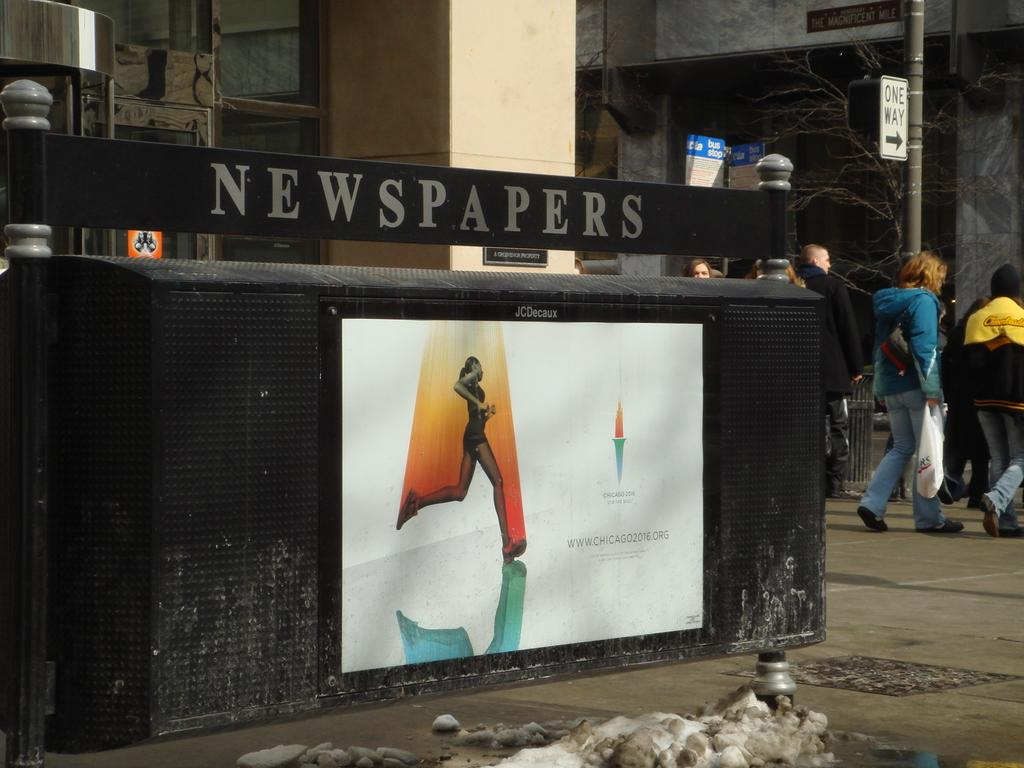How many people are in the image? There are persons in the image, but the exact number is not specified. What can be seen besides the persons in the image? There is a pole and a poster on a wall in the image. Can you describe the poster on the wall? The poster on the wall is mentioned, but no details about its content or appearance are provided. What type of text is visible in the image? There is some text visible in the image, but its content or context is not specified. What shape is the whistle in the image? There is no whistle present in the image. 